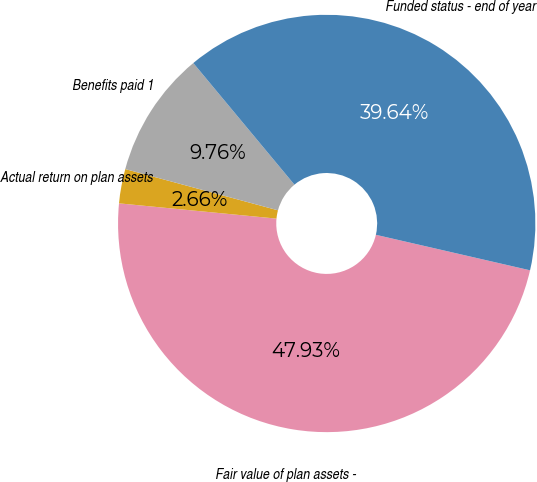Convert chart. <chart><loc_0><loc_0><loc_500><loc_500><pie_chart><fcel>Fair value of plan assets -<fcel>Actual return on plan assets<fcel>Benefits paid 1<fcel>Funded status - end of year<nl><fcel>47.93%<fcel>2.66%<fcel>9.76%<fcel>39.64%<nl></chart> 